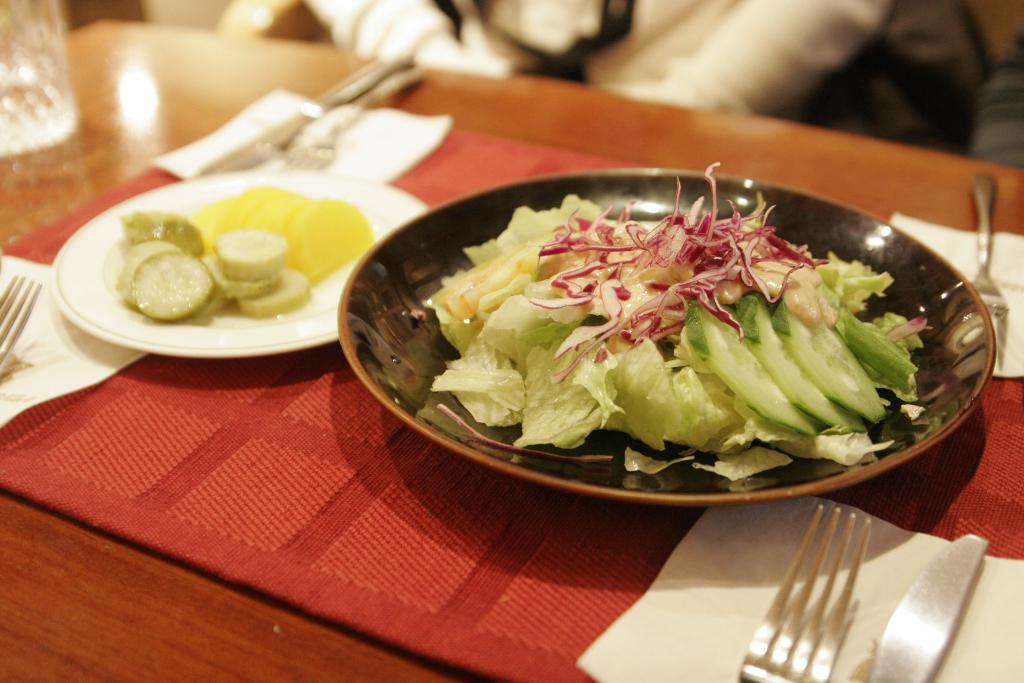Could you give a brief overview of what you see in this image? In this image, we can see a table with some objects like a cloth. We can also see some food items in plates. We can see some spoons, tissues. We can also see a white colored object at the top. 